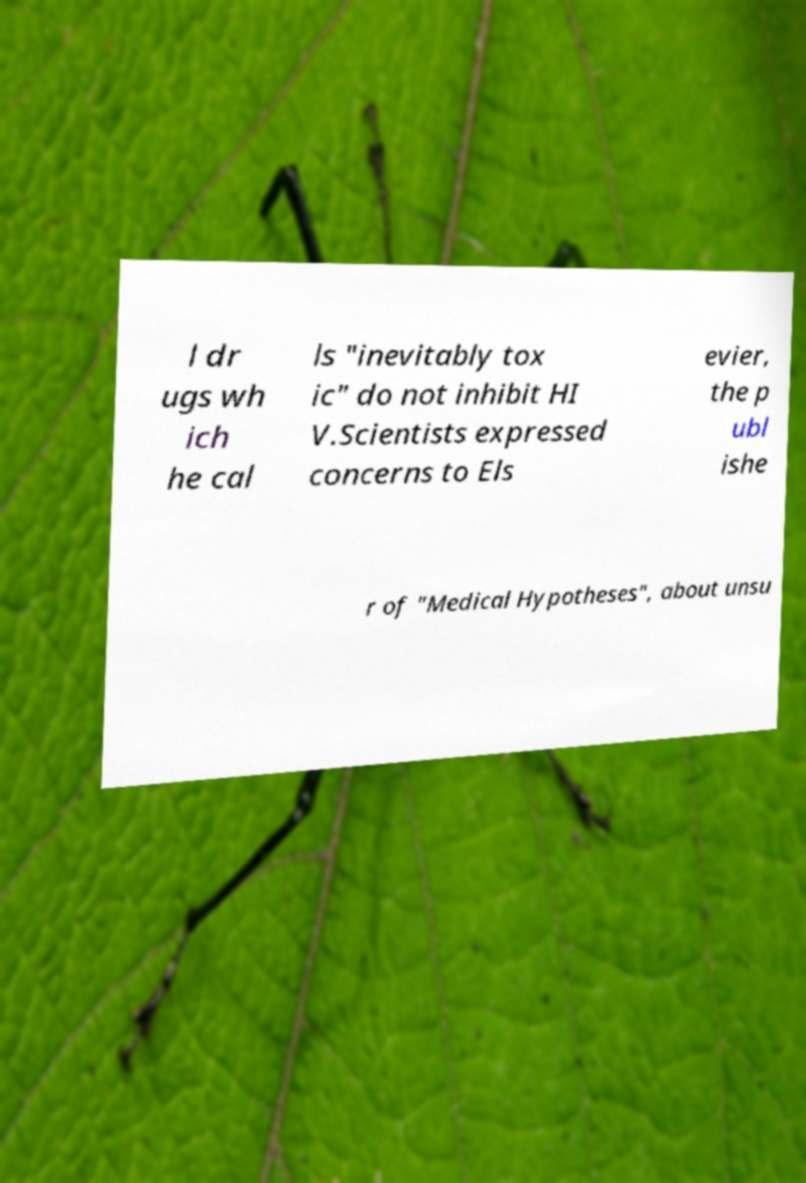I need the written content from this picture converted into text. Can you do that? l dr ugs wh ich he cal ls "inevitably tox ic" do not inhibit HI V.Scientists expressed concerns to Els evier, the p ubl ishe r of "Medical Hypotheses", about unsu 